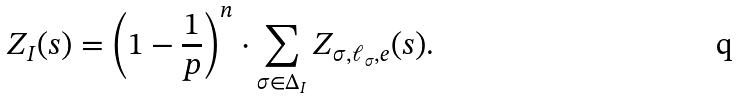Convert formula to latex. <formula><loc_0><loc_0><loc_500><loc_500>Z _ { I } ( s ) = \left ( 1 - \frac { 1 } { p } \right ) ^ { n } \cdot \sum _ { \sigma \in \Delta _ { I } } Z _ { \sigma , \ell _ { \sigma } , e } ( s ) .</formula> 